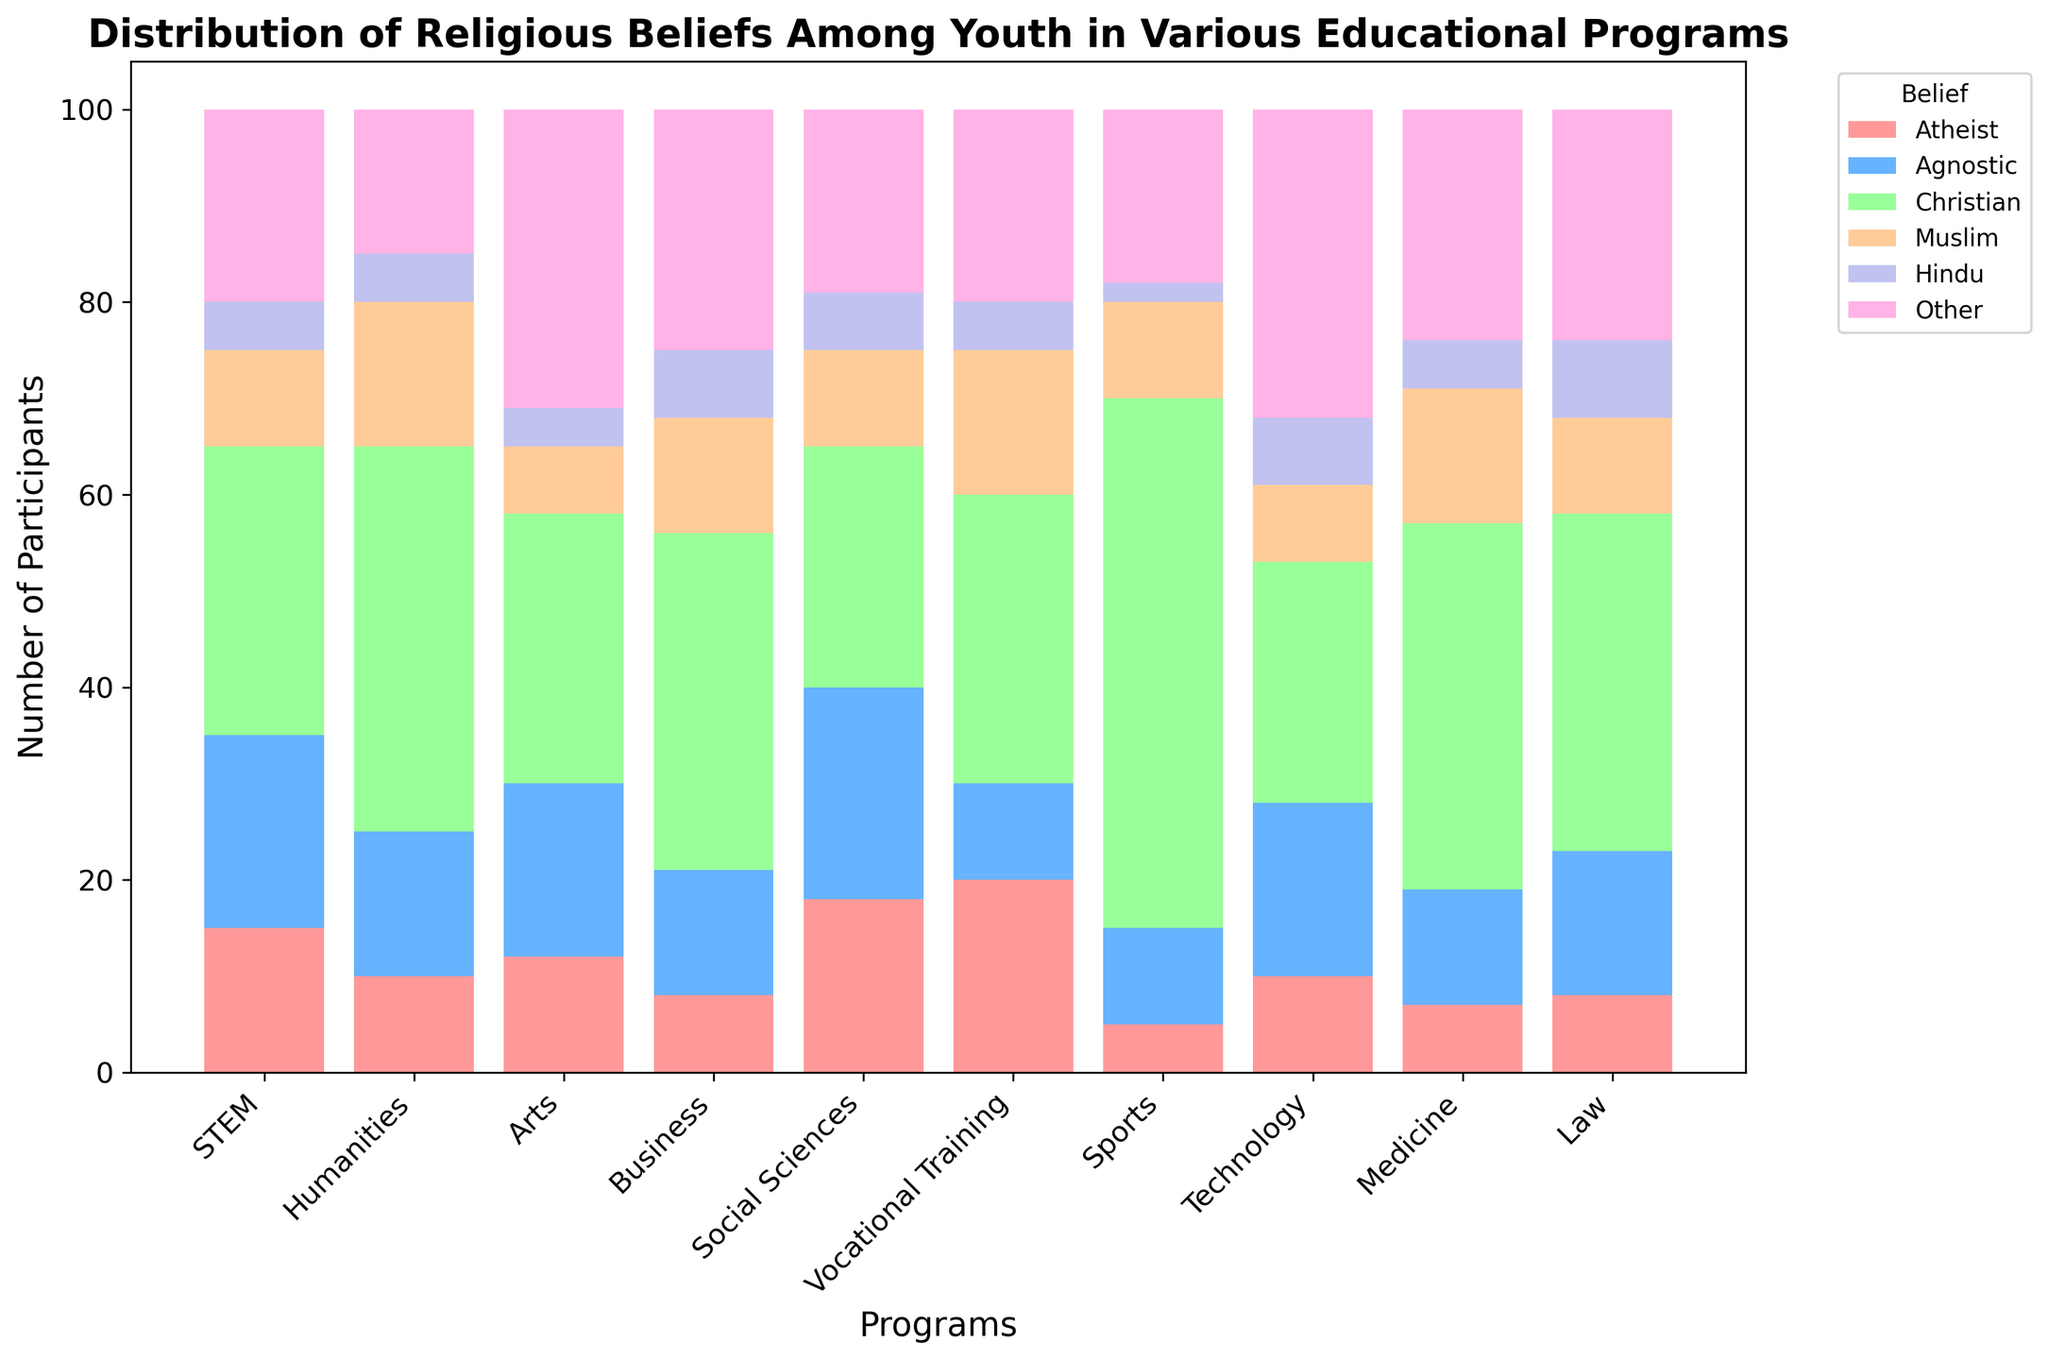Which program has the highest number of Christian participants? Observe the heights of the bars corresponding to the 'Christian' belief for each program, and compare them.
Answer: Sports What is the total number of participants in the Technology program? Sum the values of all belief categories in the Technology program (10 + 18 + 25 + 8 + 7 + 32).
Answer: 100 Which programs have an equal number of Muslim participants? Compare the heights of the 'Muslim' bars across different programs to identify any that are the same.
Answer: STEM, Social Sciences, Law (10 each) How many more Atheists are there in STEM compared to Business? Subtract the number of Atheists in Business from the number in STEM (15 - 8).
Answer: 7 Which program has the lowest number of Hindu participants? Compare the heights of the 'Hindu' bars across all programs and identify the one with the shortest bar.
Answer: Sports Is the number of Atheists higher in Vocational Training or Social Sciences? Compare the heights of the 'Atheist' bars for Vocational Training and Social Sciences.
Answer: Vocational Training What is the average number of Agnostic participants across all programs? Sum the values of Agnostic participants across all programs and divide by the number of programs ((20 + 15 + 18 + 13 + 22 + 10 + 10 + 18 + 12 + 15)/10).
Answer: 15.3 Which belief category has the widest range (difference between highest and lowest values) across all programs? Find the maximum and minimum values for each belief category, calculate the range for each, and identify the category with the highest range.
Answer: Christian Which two educational programs have the closest total number of participants? Calculate the total number of participants for each program and find the two programs with the smallest difference in totals.
Answer: STEM and Social Sciences (100 vs 100) What visual cues help identify the most dominant religious belief in Medicine? Observe the relative height and color of the bars within Medicine, where taller bars are dominant.
Answer: Christian (highest green bar) 